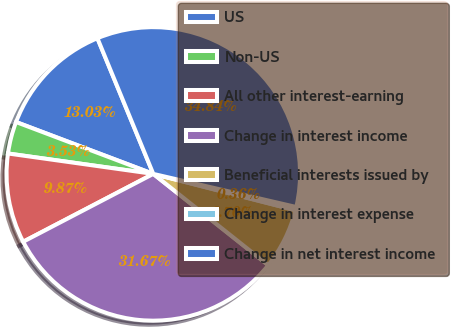<chart> <loc_0><loc_0><loc_500><loc_500><pie_chart><fcel>US<fcel>Non-US<fcel>All other interest-earning<fcel>Change in interest income<fcel>Beneficial interests issued by<fcel>Change in interest expense<fcel>Change in net interest income<nl><fcel>13.03%<fcel>3.53%<fcel>9.87%<fcel>31.67%<fcel>6.7%<fcel>0.36%<fcel>34.84%<nl></chart> 